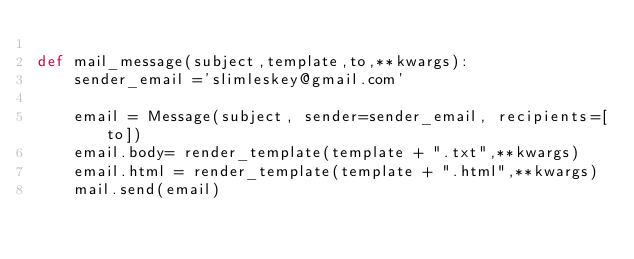Convert code to text. <code><loc_0><loc_0><loc_500><loc_500><_Python_>
def mail_message(subject,template,to,**kwargs):
    sender_email ='slimleskey@gmail.com'

    email = Message(subject, sender=sender_email, recipients=[to])
    email.body= render_template(template + ".txt",**kwargs)
    email.html = render_template(template + ".html",**kwargs)
    mail.send(email)</code> 